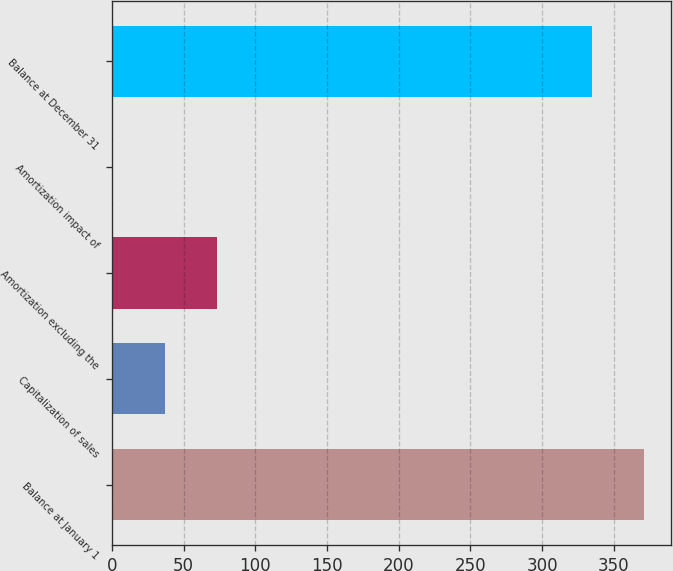<chart> <loc_0><loc_0><loc_500><loc_500><bar_chart><fcel>Balance at January 1<fcel>Capitalization of sales<fcel>Amortization excluding the<fcel>Amortization impact of<fcel>Balance at December 31<nl><fcel>371.1<fcel>37.1<fcel>73.2<fcel>1<fcel>335<nl></chart> 